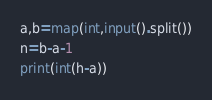<code> <loc_0><loc_0><loc_500><loc_500><_Python_>a,b=map(int,input().split())
n=b-a-1
print(int(h-a))</code> 